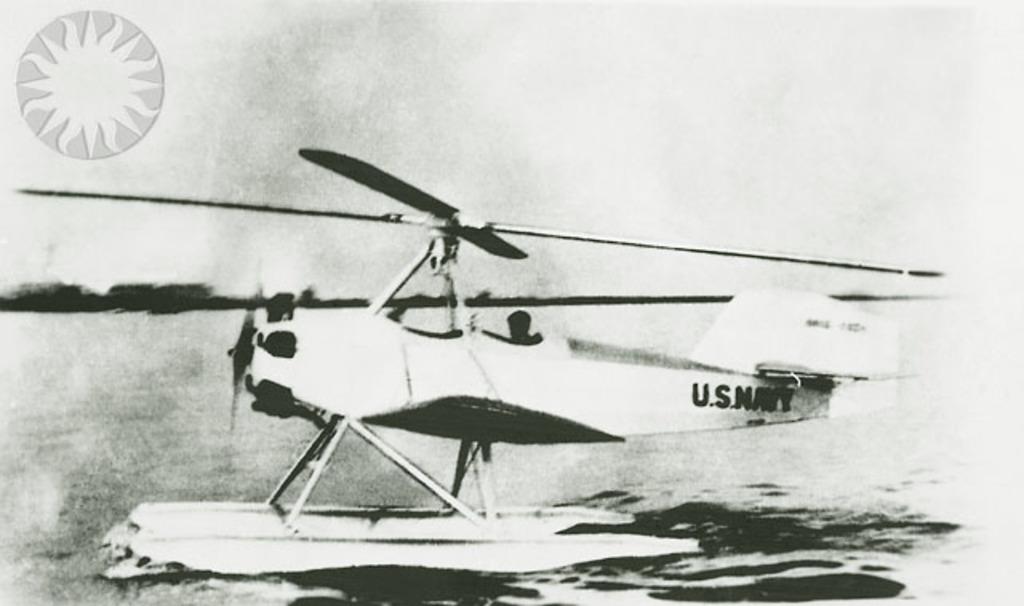What military branch owns this plane?
Provide a short and direct response. Navy. What country navy is printed on the rear of the plane?
Ensure brevity in your answer.  U.s. 